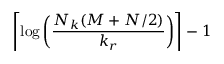Convert formula to latex. <formula><loc_0><loc_0><loc_500><loc_500>\left \lceil \log \left ( \frac { N _ { k } ( M + N / 2 ) } { k _ { r } } \right ) \right \rceil - 1</formula> 